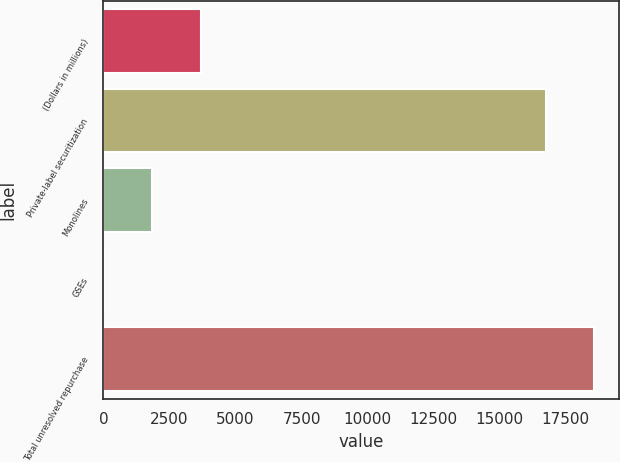<chart> <loc_0><loc_0><loc_500><loc_500><bar_chart><fcel>(Dollars in millions)<fcel>Private-label securitization<fcel>Monolines<fcel>GSEs<fcel>Total unresolved repurchase<nl><fcel>3686.4<fcel>16748<fcel>1851.7<fcel>17<fcel>18582.7<nl></chart> 